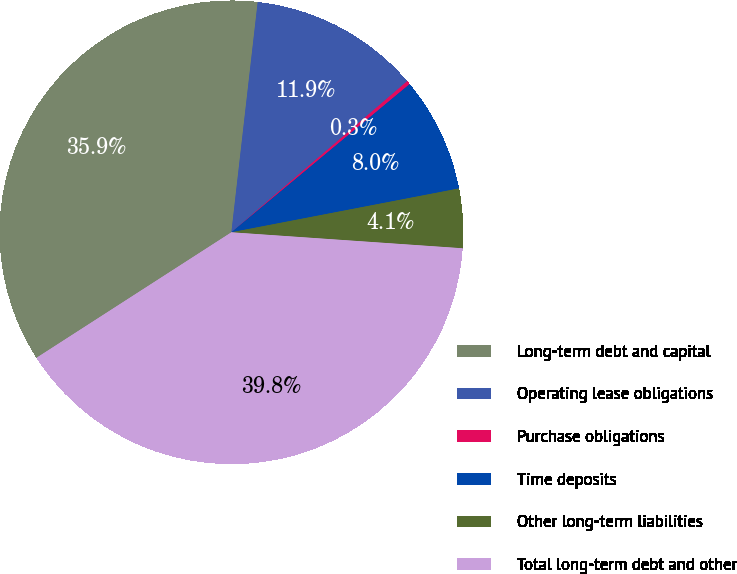Convert chart. <chart><loc_0><loc_0><loc_500><loc_500><pie_chart><fcel>Long-term debt and capital<fcel>Operating lease obligations<fcel>Purchase obligations<fcel>Time deposits<fcel>Other long-term liabilities<fcel>Total long-term debt and other<nl><fcel>35.92%<fcel>11.89%<fcel>0.26%<fcel>8.01%<fcel>4.13%<fcel>39.8%<nl></chart> 